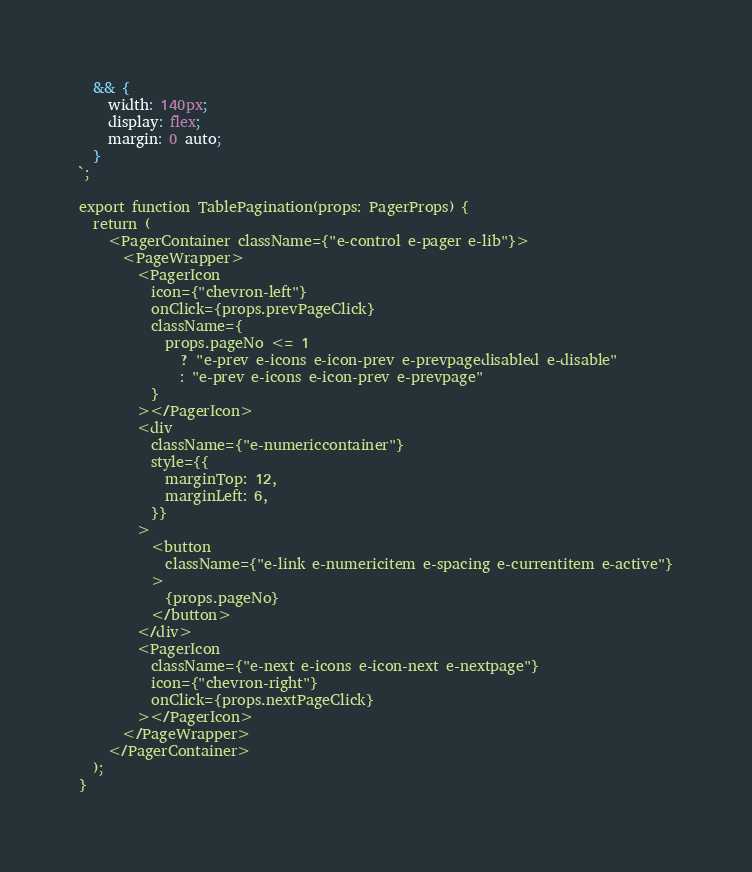<code> <loc_0><loc_0><loc_500><loc_500><_TypeScript_>  && {
    width: 140px;
    display: flex;
    margin: 0 auto;
  }
`;

export function TablePagination(props: PagerProps) {
  return (
    <PagerContainer className={"e-control e-pager e-lib"}>
      <PageWrapper>
        <PagerIcon
          icon={"chevron-left"}
          onClick={props.prevPageClick}
          className={
            props.pageNo <= 1
              ? "e-prev e-icons e-icon-prev e-prevpagedisabled e-disable"
              : "e-prev e-icons e-icon-prev e-prevpage"
          }
        ></PagerIcon>
        <div
          className={"e-numericcontainer"}
          style={{
            marginTop: 12,
            marginLeft: 6,
          }}
        >
          <button
            className={"e-link e-numericitem e-spacing e-currentitem e-active"}
          >
            {props.pageNo}
          </button>
        </div>
        <PagerIcon
          className={"e-next e-icons e-icon-next e-nextpage"}
          icon={"chevron-right"}
          onClick={props.nextPageClick}
        ></PagerIcon>
      </PageWrapper>
    </PagerContainer>
  );
}
</code> 